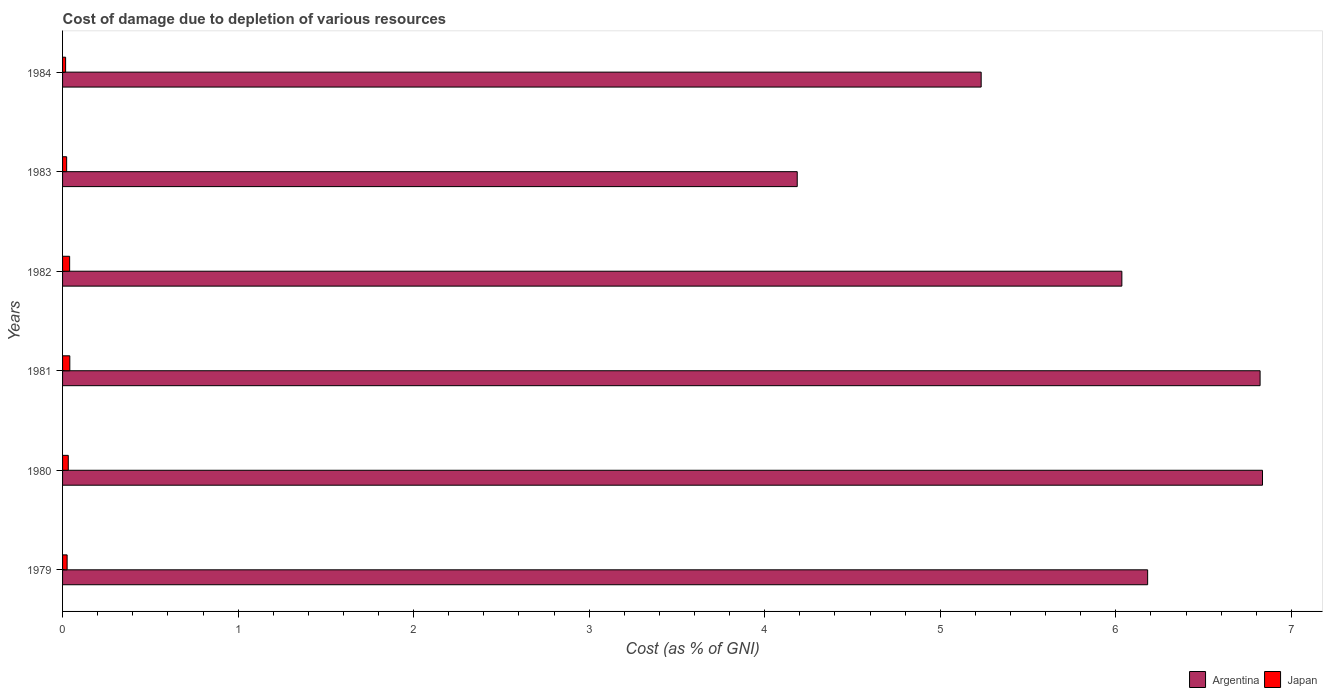Are the number of bars per tick equal to the number of legend labels?
Give a very brief answer. Yes. What is the label of the 3rd group of bars from the top?
Keep it short and to the point. 1982. What is the cost of damage caused due to the depletion of various resources in Japan in 1982?
Your answer should be very brief. 0.04. Across all years, what is the maximum cost of damage caused due to the depletion of various resources in Japan?
Offer a very short reply. 0.04. Across all years, what is the minimum cost of damage caused due to the depletion of various resources in Japan?
Your answer should be compact. 0.02. In which year was the cost of damage caused due to the depletion of various resources in Japan maximum?
Your answer should be compact. 1981. In which year was the cost of damage caused due to the depletion of various resources in Japan minimum?
Make the answer very short. 1984. What is the total cost of damage caused due to the depletion of various resources in Argentina in the graph?
Offer a very short reply. 35.29. What is the difference between the cost of damage caused due to the depletion of various resources in Japan in 1981 and that in 1984?
Keep it short and to the point. 0.02. What is the difference between the cost of damage caused due to the depletion of various resources in Argentina in 1981 and the cost of damage caused due to the depletion of various resources in Japan in 1982?
Offer a very short reply. 6.78. What is the average cost of damage caused due to the depletion of various resources in Argentina per year?
Provide a succinct answer. 5.88. In the year 1984, what is the difference between the cost of damage caused due to the depletion of various resources in Japan and cost of damage caused due to the depletion of various resources in Argentina?
Provide a short and direct response. -5.22. What is the ratio of the cost of damage caused due to the depletion of various resources in Japan in 1980 to that in 1984?
Provide a succinct answer. 1.88. Is the cost of damage caused due to the depletion of various resources in Argentina in 1980 less than that in 1981?
Make the answer very short. No. Is the difference between the cost of damage caused due to the depletion of various resources in Japan in 1979 and 1984 greater than the difference between the cost of damage caused due to the depletion of various resources in Argentina in 1979 and 1984?
Ensure brevity in your answer.  No. What is the difference between the highest and the second highest cost of damage caused due to the depletion of various resources in Japan?
Offer a terse response. 0. What is the difference between the highest and the lowest cost of damage caused due to the depletion of various resources in Argentina?
Provide a succinct answer. 2.65. Is the sum of the cost of damage caused due to the depletion of various resources in Japan in 1983 and 1984 greater than the maximum cost of damage caused due to the depletion of various resources in Argentina across all years?
Offer a very short reply. No. What does the 1st bar from the top in 1979 represents?
Offer a very short reply. Japan. Are all the bars in the graph horizontal?
Give a very brief answer. Yes. Does the graph contain any zero values?
Offer a very short reply. No. Does the graph contain grids?
Ensure brevity in your answer.  No. How many legend labels are there?
Your answer should be very brief. 2. How are the legend labels stacked?
Provide a succinct answer. Horizontal. What is the title of the graph?
Make the answer very short. Cost of damage due to depletion of various resources. What is the label or title of the X-axis?
Make the answer very short. Cost (as % of GNI). What is the label or title of the Y-axis?
Your response must be concise. Years. What is the Cost (as % of GNI) of Argentina in 1979?
Provide a short and direct response. 6.18. What is the Cost (as % of GNI) in Japan in 1979?
Give a very brief answer. 0.03. What is the Cost (as % of GNI) of Argentina in 1980?
Provide a succinct answer. 6.84. What is the Cost (as % of GNI) of Japan in 1980?
Your response must be concise. 0.03. What is the Cost (as % of GNI) in Argentina in 1981?
Offer a terse response. 6.82. What is the Cost (as % of GNI) in Japan in 1981?
Offer a terse response. 0.04. What is the Cost (as % of GNI) of Argentina in 1982?
Give a very brief answer. 6.03. What is the Cost (as % of GNI) in Japan in 1982?
Your answer should be very brief. 0.04. What is the Cost (as % of GNI) in Argentina in 1983?
Provide a succinct answer. 4.19. What is the Cost (as % of GNI) in Japan in 1983?
Make the answer very short. 0.02. What is the Cost (as % of GNI) in Argentina in 1984?
Your response must be concise. 5.23. What is the Cost (as % of GNI) in Japan in 1984?
Make the answer very short. 0.02. Across all years, what is the maximum Cost (as % of GNI) of Argentina?
Provide a succinct answer. 6.84. Across all years, what is the maximum Cost (as % of GNI) in Japan?
Your answer should be compact. 0.04. Across all years, what is the minimum Cost (as % of GNI) in Argentina?
Offer a terse response. 4.19. Across all years, what is the minimum Cost (as % of GNI) of Japan?
Keep it short and to the point. 0.02. What is the total Cost (as % of GNI) of Argentina in the graph?
Offer a terse response. 35.29. What is the total Cost (as % of GNI) in Japan in the graph?
Provide a short and direct response. 0.18. What is the difference between the Cost (as % of GNI) of Argentina in 1979 and that in 1980?
Provide a short and direct response. -0.65. What is the difference between the Cost (as % of GNI) in Japan in 1979 and that in 1980?
Give a very brief answer. -0.01. What is the difference between the Cost (as % of GNI) in Argentina in 1979 and that in 1981?
Offer a terse response. -0.64. What is the difference between the Cost (as % of GNI) of Japan in 1979 and that in 1981?
Provide a short and direct response. -0.02. What is the difference between the Cost (as % of GNI) of Argentina in 1979 and that in 1982?
Keep it short and to the point. 0.15. What is the difference between the Cost (as % of GNI) of Japan in 1979 and that in 1982?
Offer a very short reply. -0.01. What is the difference between the Cost (as % of GNI) in Argentina in 1979 and that in 1983?
Your response must be concise. 2. What is the difference between the Cost (as % of GNI) in Japan in 1979 and that in 1983?
Your answer should be very brief. 0. What is the difference between the Cost (as % of GNI) in Argentina in 1979 and that in 1984?
Your answer should be very brief. 0.95. What is the difference between the Cost (as % of GNI) of Japan in 1979 and that in 1984?
Provide a short and direct response. 0.01. What is the difference between the Cost (as % of GNI) in Argentina in 1980 and that in 1981?
Your answer should be very brief. 0.01. What is the difference between the Cost (as % of GNI) in Japan in 1980 and that in 1981?
Make the answer very short. -0.01. What is the difference between the Cost (as % of GNI) of Argentina in 1980 and that in 1982?
Your answer should be compact. 0.8. What is the difference between the Cost (as % of GNI) in Japan in 1980 and that in 1982?
Offer a very short reply. -0.01. What is the difference between the Cost (as % of GNI) in Argentina in 1980 and that in 1983?
Provide a succinct answer. 2.65. What is the difference between the Cost (as % of GNI) of Japan in 1980 and that in 1983?
Make the answer very short. 0.01. What is the difference between the Cost (as % of GNI) of Argentina in 1980 and that in 1984?
Offer a terse response. 1.6. What is the difference between the Cost (as % of GNI) of Japan in 1980 and that in 1984?
Your answer should be compact. 0.02. What is the difference between the Cost (as % of GNI) of Argentina in 1981 and that in 1982?
Give a very brief answer. 0.79. What is the difference between the Cost (as % of GNI) in Japan in 1981 and that in 1982?
Give a very brief answer. 0. What is the difference between the Cost (as % of GNI) in Argentina in 1981 and that in 1983?
Your answer should be very brief. 2.64. What is the difference between the Cost (as % of GNI) of Japan in 1981 and that in 1983?
Make the answer very short. 0.02. What is the difference between the Cost (as % of GNI) of Argentina in 1981 and that in 1984?
Your answer should be very brief. 1.59. What is the difference between the Cost (as % of GNI) in Japan in 1981 and that in 1984?
Provide a short and direct response. 0.02. What is the difference between the Cost (as % of GNI) of Argentina in 1982 and that in 1983?
Ensure brevity in your answer.  1.85. What is the difference between the Cost (as % of GNI) in Japan in 1982 and that in 1983?
Give a very brief answer. 0.02. What is the difference between the Cost (as % of GNI) in Argentina in 1982 and that in 1984?
Your response must be concise. 0.8. What is the difference between the Cost (as % of GNI) of Japan in 1982 and that in 1984?
Give a very brief answer. 0.02. What is the difference between the Cost (as % of GNI) in Argentina in 1983 and that in 1984?
Provide a succinct answer. -1.05. What is the difference between the Cost (as % of GNI) of Japan in 1983 and that in 1984?
Provide a succinct answer. 0.01. What is the difference between the Cost (as % of GNI) of Argentina in 1979 and the Cost (as % of GNI) of Japan in 1980?
Provide a succinct answer. 6.15. What is the difference between the Cost (as % of GNI) of Argentina in 1979 and the Cost (as % of GNI) of Japan in 1981?
Provide a short and direct response. 6.14. What is the difference between the Cost (as % of GNI) of Argentina in 1979 and the Cost (as % of GNI) of Japan in 1982?
Keep it short and to the point. 6.14. What is the difference between the Cost (as % of GNI) in Argentina in 1979 and the Cost (as % of GNI) in Japan in 1983?
Offer a very short reply. 6.16. What is the difference between the Cost (as % of GNI) of Argentina in 1979 and the Cost (as % of GNI) of Japan in 1984?
Provide a short and direct response. 6.16. What is the difference between the Cost (as % of GNI) in Argentina in 1980 and the Cost (as % of GNI) in Japan in 1981?
Provide a short and direct response. 6.79. What is the difference between the Cost (as % of GNI) of Argentina in 1980 and the Cost (as % of GNI) of Japan in 1982?
Offer a very short reply. 6.8. What is the difference between the Cost (as % of GNI) in Argentina in 1980 and the Cost (as % of GNI) in Japan in 1983?
Your answer should be very brief. 6.81. What is the difference between the Cost (as % of GNI) of Argentina in 1980 and the Cost (as % of GNI) of Japan in 1984?
Offer a terse response. 6.82. What is the difference between the Cost (as % of GNI) of Argentina in 1981 and the Cost (as % of GNI) of Japan in 1982?
Offer a terse response. 6.78. What is the difference between the Cost (as % of GNI) in Argentina in 1981 and the Cost (as % of GNI) in Japan in 1983?
Your answer should be very brief. 6.8. What is the difference between the Cost (as % of GNI) of Argentina in 1981 and the Cost (as % of GNI) of Japan in 1984?
Your answer should be very brief. 6.8. What is the difference between the Cost (as % of GNI) of Argentina in 1982 and the Cost (as % of GNI) of Japan in 1983?
Offer a terse response. 6.01. What is the difference between the Cost (as % of GNI) of Argentina in 1982 and the Cost (as % of GNI) of Japan in 1984?
Offer a very short reply. 6.02. What is the difference between the Cost (as % of GNI) of Argentina in 1983 and the Cost (as % of GNI) of Japan in 1984?
Ensure brevity in your answer.  4.17. What is the average Cost (as % of GNI) of Argentina per year?
Keep it short and to the point. 5.88. What is the average Cost (as % of GNI) of Japan per year?
Your answer should be compact. 0.03. In the year 1979, what is the difference between the Cost (as % of GNI) in Argentina and Cost (as % of GNI) in Japan?
Ensure brevity in your answer.  6.16. In the year 1980, what is the difference between the Cost (as % of GNI) in Argentina and Cost (as % of GNI) in Japan?
Give a very brief answer. 6.8. In the year 1981, what is the difference between the Cost (as % of GNI) in Argentina and Cost (as % of GNI) in Japan?
Your answer should be compact. 6.78. In the year 1982, what is the difference between the Cost (as % of GNI) of Argentina and Cost (as % of GNI) of Japan?
Offer a terse response. 5.99. In the year 1983, what is the difference between the Cost (as % of GNI) in Argentina and Cost (as % of GNI) in Japan?
Your answer should be compact. 4.16. In the year 1984, what is the difference between the Cost (as % of GNI) in Argentina and Cost (as % of GNI) in Japan?
Provide a succinct answer. 5.22. What is the ratio of the Cost (as % of GNI) of Argentina in 1979 to that in 1980?
Make the answer very short. 0.9. What is the ratio of the Cost (as % of GNI) in Japan in 1979 to that in 1980?
Ensure brevity in your answer.  0.8. What is the ratio of the Cost (as % of GNI) of Argentina in 1979 to that in 1981?
Offer a terse response. 0.91. What is the ratio of the Cost (as % of GNI) in Japan in 1979 to that in 1981?
Your response must be concise. 0.63. What is the ratio of the Cost (as % of GNI) of Argentina in 1979 to that in 1982?
Ensure brevity in your answer.  1.02. What is the ratio of the Cost (as % of GNI) in Japan in 1979 to that in 1982?
Ensure brevity in your answer.  0.64. What is the ratio of the Cost (as % of GNI) of Argentina in 1979 to that in 1983?
Ensure brevity in your answer.  1.48. What is the ratio of the Cost (as % of GNI) of Japan in 1979 to that in 1983?
Your answer should be very brief. 1.11. What is the ratio of the Cost (as % of GNI) in Argentina in 1979 to that in 1984?
Ensure brevity in your answer.  1.18. What is the ratio of the Cost (as % of GNI) in Japan in 1979 to that in 1984?
Your response must be concise. 1.5. What is the ratio of the Cost (as % of GNI) of Japan in 1980 to that in 1981?
Offer a terse response. 0.79. What is the ratio of the Cost (as % of GNI) of Argentina in 1980 to that in 1982?
Give a very brief answer. 1.13. What is the ratio of the Cost (as % of GNI) of Japan in 1980 to that in 1982?
Provide a succinct answer. 0.81. What is the ratio of the Cost (as % of GNI) of Argentina in 1980 to that in 1983?
Offer a terse response. 1.63. What is the ratio of the Cost (as % of GNI) of Japan in 1980 to that in 1983?
Your answer should be compact. 1.4. What is the ratio of the Cost (as % of GNI) in Argentina in 1980 to that in 1984?
Provide a succinct answer. 1.31. What is the ratio of the Cost (as % of GNI) of Japan in 1980 to that in 1984?
Offer a very short reply. 1.88. What is the ratio of the Cost (as % of GNI) in Argentina in 1981 to that in 1982?
Provide a short and direct response. 1.13. What is the ratio of the Cost (as % of GNI) in Japan in 1981 to that in 1982?
Provide a succinct answer. 1.02. What is the ratio of the Cost (as % of GNI) of Argentina in 1981 to that in 1983?
Your answer should be compact. 1.63. What is the ratio of the Cost (as % of GNI) of Japan in 1981 to that in 1983?
Provide a short and direct response. 1.77. What is the ratio of the Cost (as % of GNI) in Argentina in 1981 to that in 1984?
Provide a short and direct response. 1.3. What is the ratio of the Cost (as % of GNI) of Japan in 1981 to that in 1984?
Your response must be concise. 2.38. What is the ratio of the Cost (as % of GNI) of Argentina in 1982 to that in 1983?
Offer a terse response. 1.44. What is the ratio of the Cost (as % of GNI) of Japan in 1982 to that in 1983?
Your answer should be compact. 1.73. What is the ratio of the Cost (as % of GNI) in Argentina in 1982 to that in 1984?
Your answer should be very brief. 1.15. What is the ratio of the Cost (as % of GNI) in Japan in 1982 to that in 1984?
Your answer should be compact. 2.32. What is the ratio of the Cost (as % of GNI) of Argentina in 1983 to that in 1984?
Make the answer very short. 0.8. What is the ratio of the Cost (as % of GNI) in Japan in 1983 to that in 1984?
Make the answer very short. 1.34. What is the difference between the highest and the second highest Cost (as % of GNI) in Argentina?
Your answer should be compact. 0.01. What is the difference between the highest and the second highest Cost (as % of GNI) of Japan?
Keep it short and to the point. 0. What is the difference between the highest and the lowest Cost (as % of GNI) in Argentina?
Offer a very short reply. 2.65. What is the difference between the highest and the lowest Cost (as % of GNI) of Japan?
Offer a terse response. 0.02. 